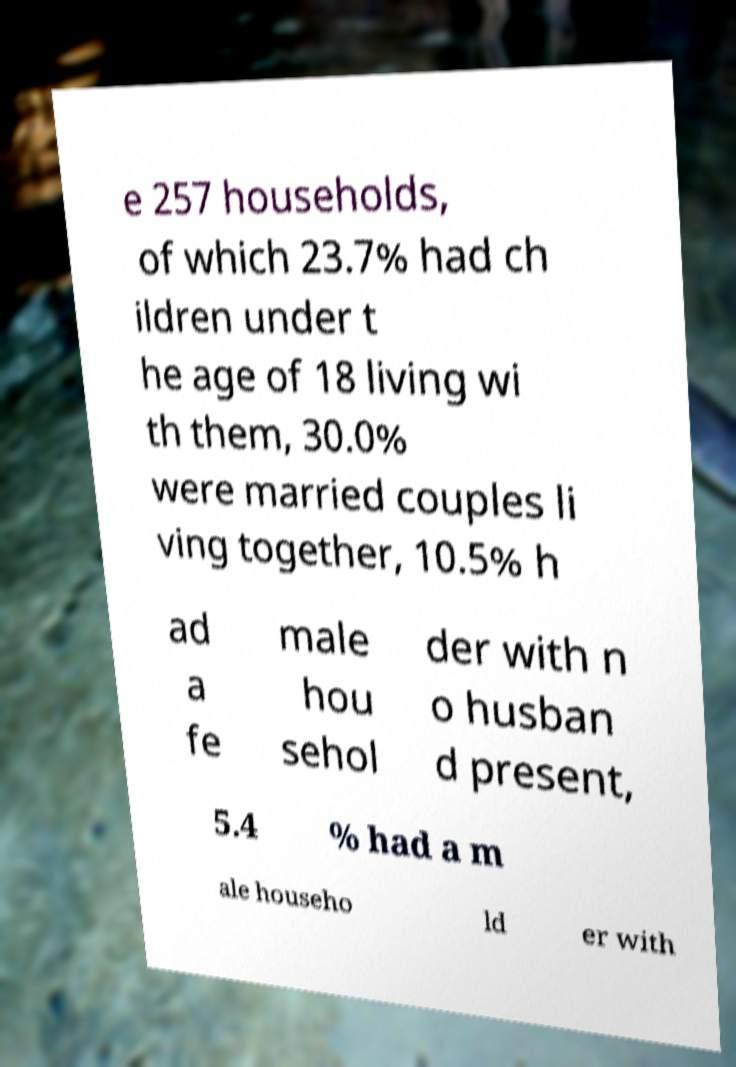What messages or text are displayed in this image? I need them in a readable, typed format. e 257 households, of which 23.7% had ch ildren under t he age of 18 living wi th them, 30.0% were married couples li ving together, 10.5% h ad a fe male hou sehol der with n o husban d present, 5.4 % had a m ale househo ld er with 